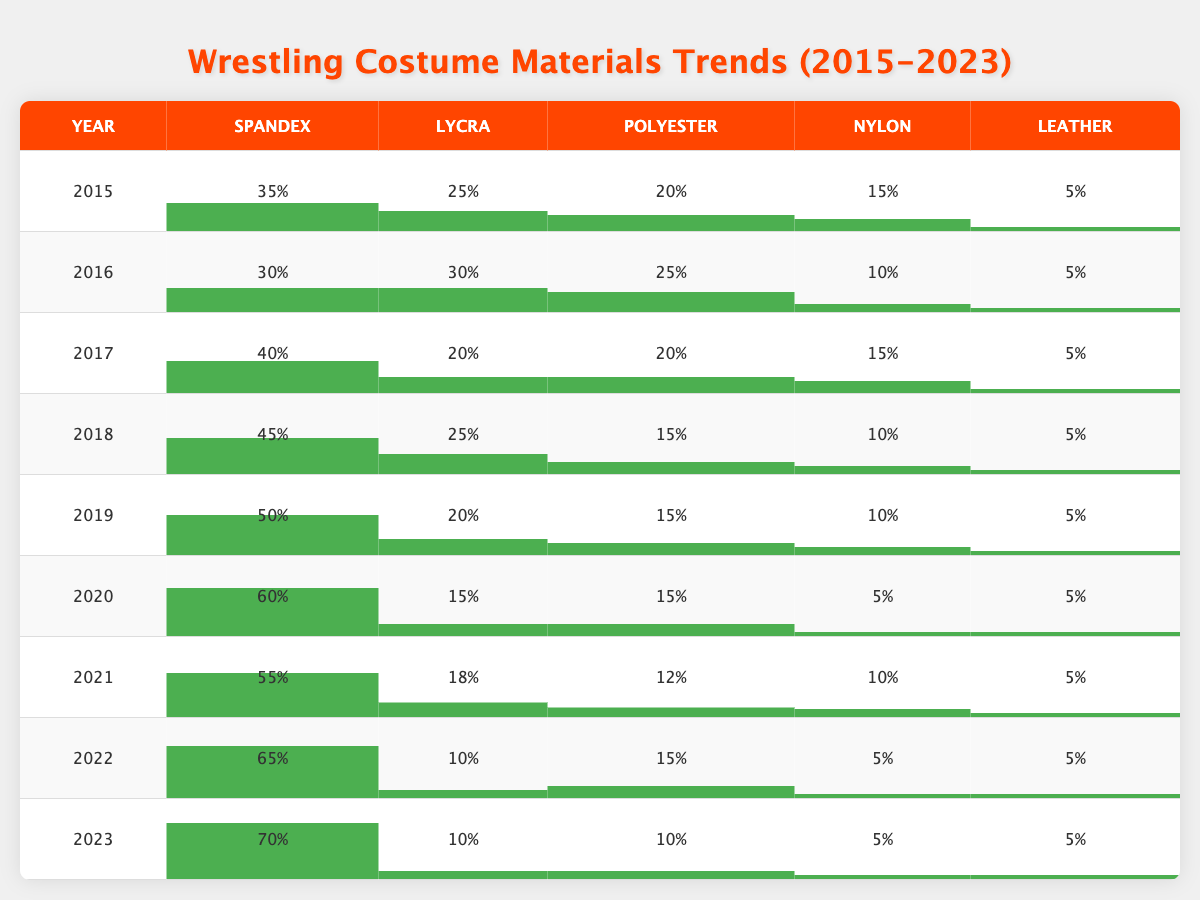What was the most popular material for wrestling costumes in 2023? In 2023, Spandex is the material with the highest percentage, at 70%.
Answer: 70% Which year saw the highest percentage of Lycra use? By looking at the table, the highest percentage of Lycra was in 2016, at 30%.
Answer: 30% How much did the use of Polyester decrease from 2015 to 2022? In 2015, Polyester usage was 20%, and by 2022, it was 15%. The decrease is 20% - 15% = 5%.
Answer: 5% Is the percentage of Leather used in wrestling costumes consistent from 2015 to 2023? Yes, throughout the years from 2015 to 2023, Leather consistently remained at 5%.
Answer: Yes What percentage of costume materials was made up of both Spandex and Lycra in 2021? In 2021, Spandex was 55% and Lycra was 18%. Summing them gives 55% + 18% = 73%.
Answer: 73% Did the percentage of Spandex used in costumes increase every year from 2015 to 2023? Yes, checking the values from 2015 to 2023 shows an increasing trend for Spandex: 35%, 30%, 40%, 45%, 50%, 60%, 55%, 65%, and 70%.
Answer: Yes What was the average percentage of Nylon used between 2015 and 2023? The percentages for Nylon are 15%, 10%, 15%, 10%, 10%, 5%, 5%, and 5%. Adding them gives 75%, and dividing by 8 gives an average of 9.375%.
Answer: 9.375% Which material has shown the most significant increase from 2015 to 2023? Analyzing the data, Spandex increased from 35% in 2015 to 70% in 2023, which is an increase of 35%.
Answer: 35% In which year did the use of Polyester show a peak compared to other years? The usage of Polyester peaked at 25% in 2016.
Answer: 25% What trend is observed in the use of Lycra over the years? Lycra usage generally decreased from 2015 (25%) down to 10% in 2023.
Answer: Decreased 